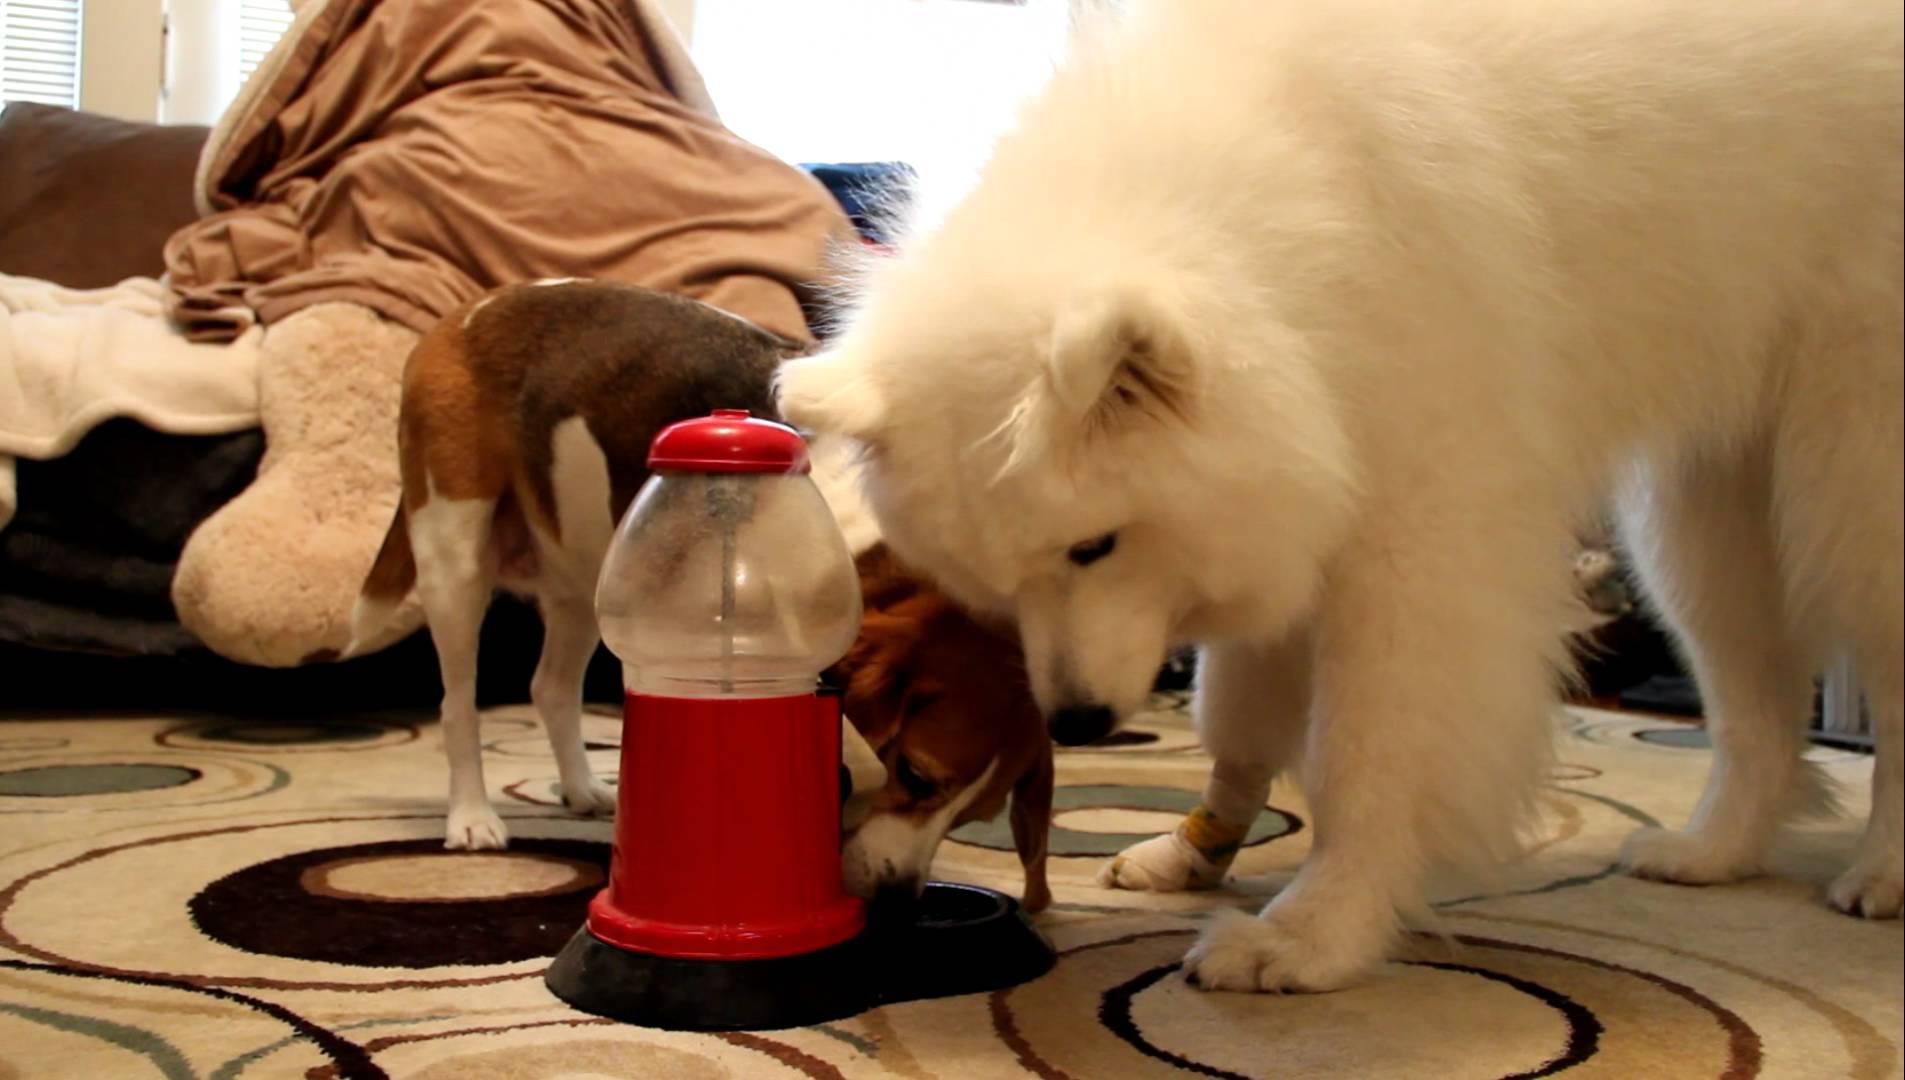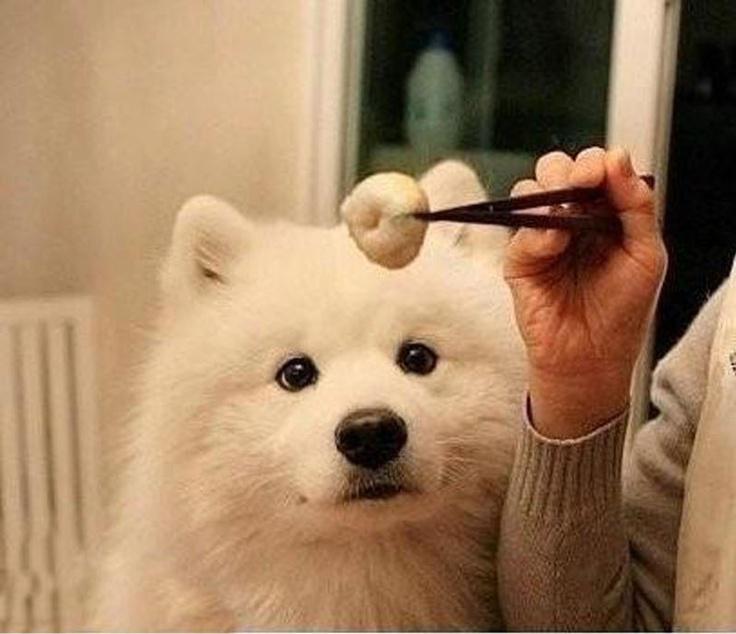The first image is the image on the left, the second image is the image on the right. For the images displayed, is the sentence "A person is placing something on a table in front of a dog in only one of the images." factually correct? Answer yes or no. No. The first image is the image on the left, the second image is the image on the right. Considering the images on both sides, is "An image shows a person's hand reaching from the right to offer something tasty to a white dog." valid? Answer yes or no. Yes. 